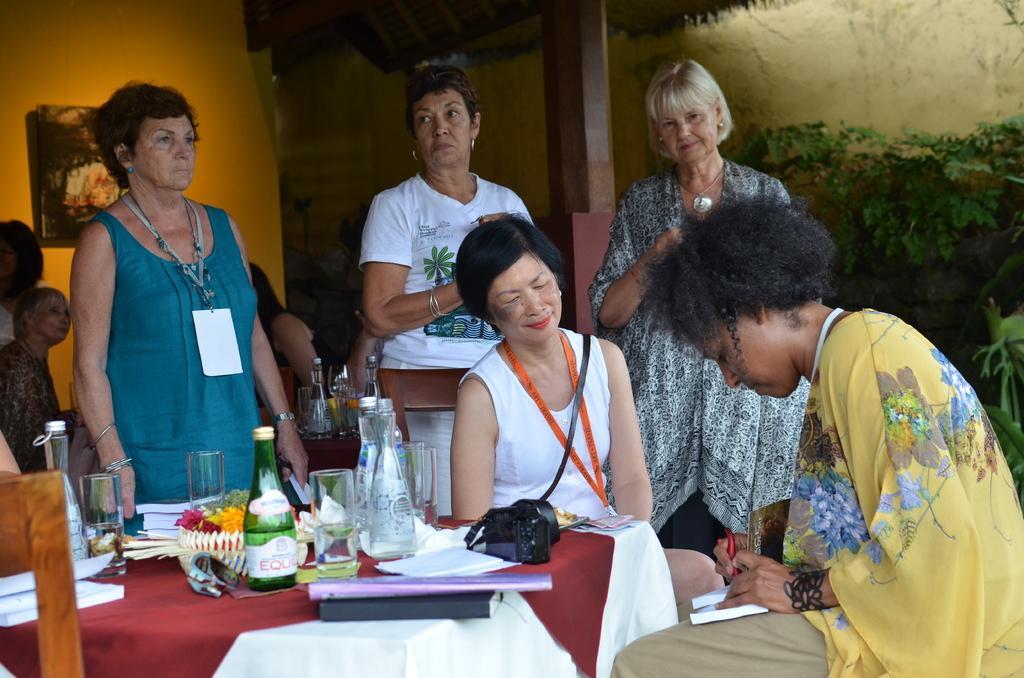Can you describe this image briefly? There are three women standing and two women sitting on the chairs. This is the tale covered with the cloth. This is the camera,bottle,glass tumbler,flowers,files and papers placed on the table. At background I can see three people standing. This is the frame attached to the wall. This looks like the wooden pillar. These are the trees. 